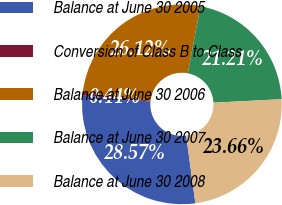Convert chart to OTSL. <chart><loc_0><loc_0><loc_500><loc_500><pie_chart><fcel>Balance at June 30 2005<fcel>Conversion of Class B to Class<fcel>Balance at June 30 2006<fcel>Balance at June 30 2007<fcel>Balance at June 30 2008<nl><fcel>28.57%<fcel>0.44%<fcel>26.12%<fcel>21.21%<fcel>23.66%<nl></chart> 